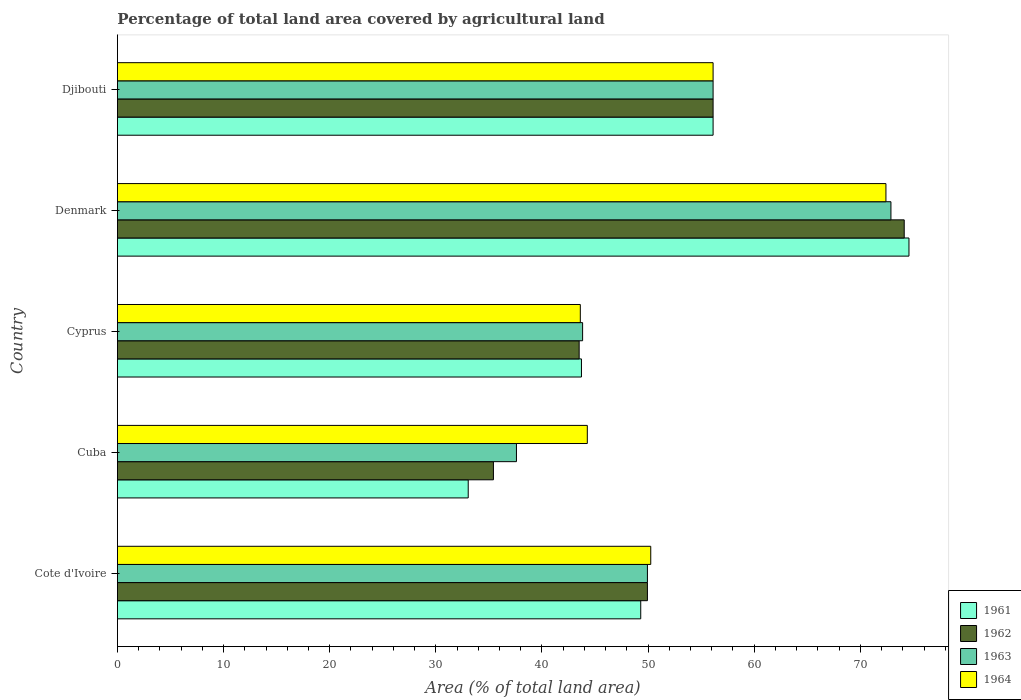How many different coloured bars are there?
Give a very brief answer. 4. What is the label of the 4th group of bars from the top?
Give a very brief answer. Cuba. What is the percentage of agricultural land in 1961 in Djibouti?
Provide a short and direct response. 56.13. Across all countries, what is the maximum percentage of agricultural land in 1964?
Offer a very short reply. 72.41. Across all countries, what is the minimum percentage of agricultural land in 1961?
Provide a short and direct response. 33.05. In which country was the percentage of agricultural land in 1962 maximum?
Provide a short and direct response. Denmark. In which country was the percentage of agricultural land in 1961 minimum?
Ensure brevity in your answer.  Cuba. What is the total percentage of agricultural land in 1964 in the graph?
Provide a short and direct response. 266.68. What is the difference between the percentage of agricultural land in 1961 in Cote d'Ivoire and that in Cuba?
Give a very brief answer. 16.25. What is the difference between the percentage of agricultural land in 1963 in Denmark and the percentage of agricultural land in 1961 in Djibouti?
Your answer should be compact. 16.76. What is the average percentage of agricultural land in 1961 per country?
Make the answer very short. 51.36. What is the difference between the percentage of agricultural land in 1962 and percentage of agricultural land in 1963 in Denmark?
Make the answer very short. 1.25. In how many countries, is the percentage of agricultural land in 1961 greater than 32 %?
Give a very brief answer. 5. What is the ratio of the percentage of agricultural land in 1964 in Cote d'Ivoire to that in Cyprus?
Provide a succinct answer. 1.15. Is the difference between the percentage of agricultural land in 1962 in Cyprus and Djibouti greater than the difference between the percentage of agricultural land in 1963 in Cyprus and Djibouti?
Keep it short and to the point. No. What is the difference between the highest and the second highest percentage of agricultural land in 1964?
Provide a short and direct response. 16.28. What is the difference between the highest and the lowest percentage of agricultural land in 1962?
Your answer should be very brief. 38.7. Is the sum of the percentage of agricultural land in 1961 in Cuba and Denmark greater than the maximum percentage of agricultural land in 1964 across all countries?
Offer a terse response. Yes. What does the 2nd bar from the bottom in Denmark represents?
Your answer should be very brief. 1962. How many countries are there in the graph?
Your answer should be very brief. 5. What is the difference between two consecutive major ticks on the X-axis?
Keep it short and to the point. 10. Are the values on the major ticks of X-axis written in scientific E-notation?
Keep it short and to the point. No. Does the graph contain any zero values?
Your response must be concise. No. Where does the legend appear in the graph?
Provide a succinct answer. Bottom right. How many legend labels are there?
Ensure brevity in your answer.  4. How are the legend labels stacked?
Give a very brief answer. Vertical. What is the title of the graph?
Keep it short and to the point. Percentage of total land area covered by agricultural land. What is the label or title of the X-axis?
Make the answer very short. Area (% of total land area). What is the Area (% of total land area) of 1961 in Cote d'Ivoire?
Offer a terse response. 49.31. What is the Area (% of total land area) in 1962 in Cote d'Ivoire?
Ensure brevity in your answer.  49.94. What is the Area (% of total land area) of 1963 in Cote d'Ivoire?
Provide a short and direct response. 49.94. What is the Area (% of total land area) of 1964 in Cote d'Ivoire?
Keep it short and to the point. 50.25. What is the Area (% of total land area) of 1961 in Cuba?
Offer a very short reply. 33.05. What is the Area (% of total land area) in 1962 in Cuba?
Provide a short and direct response. 35.43. What is the Area (% of total land area) in 1963 in Cuba?
Ensure brevity in your answer.  37.6. What is the Area (% of total land area) in 1964 in Cuba?
Keep it short and to the point. 44.27. What is the Area (% of total land area) of 1961 in Cyprus?
Your answer should be very brief. 43.72. What is the Area (% of total land area) in 1962 in Cyprus?
Offer a very short reply. 43.51. What is the Area (% of total land area) of 1963 in Cyprus?
Your answer should be very brief. 43.83. What is the Area (% of total land area) in 1964 in Cyprus?
Your answer should be very brief. 43.61. What is the Area (% of total land area) of 1961 in Denmark?
Offer a very short reply. 74.58. What is the Area (% of total land area) in 1962 in Denmark?
Your response must be concise. 74.13. What is the Area (% of total land area) of 1963 in Denmark?
Keep it short and to the point. 72.88. What is the Area (% of total land area) in 1964 in Denmark?
Offer a terse response. 72.41. What is the Area (% of total land area) of 1961 in Djibouti?
Your response must be concise. 56.13. What is the Area (% of total land area) of 1962 in Djibouti?
Your response must be concise. 56.13. What is the Area (% of total land area) of 1963 in Djibouti?
Your answer should be compact. 56.13. What is the Area (% of total land area) in 1964 in Djibouti?
Keep it short and to the point. 56.13. Across all countries, what is the maximum Area (% of total land area) in 1961?
Your answer should be very brief. 74.58. Across all countries, what is the maximum Area (% of total land area) of 1962?
Offer a very short reply. 74.13. Across all countries, what is the maximum Area (% of total land area) of 1963?
Offer a terse response. 72.88. Across all countries, what is the maximum Area (% of total land area) in 1964?
Ensure brevity in your answer.  72.41. Across all countries, what is the minimum Area (% of total land area) in 1961?
Provide a short and direct response. 33.05. Across all countries, what is the minimum Area (% of total land area) of 1962?
Provide a short and direct response. 35.43. Across all countries, what is the minimum Area (% of total land area) of 1963?
Provide a short and direct response. 37.6. Across all countries, what is the minimum Area (% of total land area) in 1964?
Offer a very short reply. 43.61. What is the total Area (% of total land area) in 1961 in the graph?
Your answer should be very brief. 256.79. What is the total Area (% of total land area) of 1962 in the graph?
Your answer should be compact. 259.13. What is the total Area (% of total land area) of 1963 in the graph?
Your answer should be very brief. 260.37. What is the total Area (% of total land area) in 1964 in the graph?
Your answer should be compact. 266.68. What is the difference between the Area (% of total land area) in 1961 in Cote d'Ivoire and that in Cuba?
Your answer should be compact. 16.25. What is the difference between the Area (% of total land area) of 1962 in Cote d'Ivoire and that in Cuba?
Ensure brevity in your answer.  14.51. What is the difference between the Area (% of total land area) in 1963 in Cote d'Ivoire and that in Cuba?
Ensure brevity in your answer.  12.34. What is the difference between the Area (% of total land area) in 1964 in Cote d'Ivoire and that in Cuba?
Ensure brevity in your answer.  5.98. What is the difference between the Area (% of total land area) of 1961 in Cote d'Ivoire and that in Cyprus?
Offer a very short reply. 5.59. What is the difference between the Area (% of total land area) in 1962 in Cote d'Ivoire and that in Cyprus?
Your answer should be very brief. 6.43. What is the difference between the Area (% of total land area) in 1963 in Cote d'Ivoire and that in Cyprus?
Offer a terse response. 6.11. What is the difference between the Area (% of total land area) in 1964 in Cote d'Ivoire and that in Cyprus?
Offer a terse response. 6.64. What is the difference between the Area (% of total land area) in 1961 in Cote d'Ivoire and that in Denmark?
Provide a short and direct response. -25.27. What is the difference between the Area (% of total land area) in 1962 in Cote d'Ivoire and that in Denmark?
Keep it short and to the point. -24.2. What is the difference between the Area (% of total land area) in 1963 in Cote d'Ivoire and that in Denmark?
Give a very brief answer. -22.94. What is the difference between the Area (% of total land area) in 1964 in Cote d'Ivoire and that in Denmark?
Your answer should be very brief. -22.16. What is the difference between the Area (% of total land area) of 1961 in Cote d'Ivoire and that in Djibouti?
Your answer should be compact. -6.82. What is the difference between the Area (% of total land area) of 1962 in Cote d'Ivoire and that in Djibouti?
Ensure brevity in your answer.  -6.19. What is the difference between the Area (% of total land area) in 1963 in Cote d'Ivoire and that in Djibouti?
Provide a succinct answer. -6.19. What is the difference between the Area (% of total land area) in 1964 in Cote d'Ivoire and that in Djibouti?
Your answer should be compact. -5.87. What is the difference between the Area (% of total land area) in 1961 in Cuba and that in Cyprus?
Offer a terse response. -10.67. What is the difference between the Area (% of total land area) of 1962 in Cuba and that in Cyprus?
Provide a succinct answer. -8.08. What is the difference between the Area (% of total land area) of 1963 in Cuba and that in Cyprus?
Your response must be concise. -6.23. What is the difference between the Area (% of total land area) in 1964 in Cuba and that in Cyprus?
Give a very brief answer. 0.66. What is the difference between the Area (% of total land area) in 1961 in Cuba and that in Denmark?
Provide a short and direct response. -41.53. What is the difference between the Area (% of total land area) in 1962 in Cuba and that in Denmark?
Give a very brief answer. -38.7. What is the difference between the Area (% of total land area) of 1963 in Cuba and that in Denmark?
Provide a succinct answer. -35.28. What is the difference between the Area (% of total land area) in 1964 in Cuba and that in Denmark?
Give a very brief answer. -28.14. What is the difference between the Area (% of total land area) in 1961 in Cuba and that in Djibouti?
Ensure brevity in your answer.  -23.07. What is the difference between the Area (% of total land area) of 1962 in Cuba and that in Djibouti?
Offer a very short reply. -20.7. What is the difference between the Area (% of total land area) in 1963 in Cuba and that in Djibouti?
Your answer should be compact. -18.53. What is the difference between the Area (% of total land area) in 1964 in Cuba and that in Djibouti?
Your answer should be compact. -11.85. What is the difference between the Area (% of total land area) of 1961 in Cyprus and that in Denmark?
Provide a short and direct response. -30.86. What is the difference between the Area (% of total land area) in 1962 in Cyprus and that in Denmark?
Your answer should be compact. -30.63. What is the difference between the Area (% of total land area) in 1963 in Cyprus and that in Denmark?
Give a very brief answer. -29.05. What is the difference between the Area (% of total land area) in 1964 in Cyprus and that in Denmark?
Offer a terse response. -28.8. What is the difference between the Area (% of total land area) of 1961 in Cyprus and that in Djibouti?
Offer a very short reply. -12.4. What is the difference between the Area (% of total land area) of 1962 in Cyprus and that in Djibouti?
Make the answer very short. -12.62. What is the difference between the Area (% of total land area) of 1963 in Cyprus and that in Djibouti?
Ensure brevity in your answer.  -12.29. What is the difference between the Area (% of total land area) in 1964 in Cyprus and that in Djibouti?
Keep it short and to the point. -12.51. What is the difference between the Area (% of total land area) in 1961 in Denmark and that in Djibouti?
Keep it short and to the point. 18.46. What is the difference between the Area (% of total land area) in 1962 in Denmark and that in Djibouti?
Your answer should be very brief. 18.01. What is the difference between the Area (% of total land area) in 1963 in Denmark and that in Djibouti?
Give a very brief answer. 16.76. What is the difference between the Area (% of total land area) of 1964 in Denmark and that in Djibouti?
Make the answer very short. 16.28. What is the difference between the Area (% of total land area) in 1961 in Cote d'Ivoire and the Area (% of total land area) in 1962 in Cuba?
Give a very brief answer. 13.88. What is the difference between the Area (% of total land area) in 1961 in Cote d'Ivoire and the Area (% of total land area) in 1963 in Cuba?
Provide a succinct answer. 11.71. What is the difference between the Area (% of total land area) of 1961 in Cote d'Ivoire and the Area (% of total land area) of 1964 in Cuba?
Your answer should be very brief. 5.03. What is the difference between the Area (% of total land area) of 1962 in Cote d'Ivoire and the Area (% of total land area) of 1963 in Cuba?
Offer a very short reply. 12.34. What is the difference between the Area (% of total land area) in 1962 in Cote d'Ivoire and the Area (% of total land area) in 1964 in Cuba?
Ensure brevity in your answer.  5.66. What is the difference between the Area (% of total land area) in 1963 in Cote d'Ivoire and the Area (% of total land area) in 1964 in Cuba?
Provide a short and direct response. 5.66. What is the difference between the Area (% of total land area) in 1961 in Cote d'Ivoire and the Area (% of total land area) in 1962 in Cyprus?
Your answer should be compact. 5.8. What is the difference between the Area (% of total land area) of 1961 in Cote d'Ivoire and the Area (% of total land area) of 1963 in Cyprus?
Offer a very short reply. 5.48. What is the difference between the Area (% of total land area) of 1961 in Cote d'Ivoire and the Area (% of total land area) of 1964 in Cyprus?
Give a very brief answer. 5.69. What is the difference between the Area (% of total land area) of 1962 in Cote d'Ivoire and the Area (% of total land area) of 1963 in Cyprus?
Provide a short and direct response. 6.11. What is the difference between the Area (% of total land area) of 1962 in Cote d'Ivoire and the Area (% of total land area) of 1964 in Cyprus?
Provide a succinct answer. 6.32. What is the difference between the Area (% of total land area) of 1963 in Cote d'Ivoire and the Area (% of total land area) of 1964 in Cyprus?
Make the answer very short. 6.32. What is the difference between the Area (% of total land area) in 1961 in Cote d'Ivoire and the Area (% of total land area) in 1962 in Denmark?
Your answer should be very brief. -24.82. What is the difference between the Area (% of total land area) of 1961 in Cote d'Ivoire and the Area (% of total land area) of 1963 in Denmark?
Make the answer very short. -23.57. What is the difference between the Area (% of total land area) of 1961 in Cote d'Ivoire and the Area (% of total land area) of 1964 in Denmark?
Keep it short and to the point. -23.1. What is the difference between the Area (% of total land area) of 1962 in Cote d'Ivoire and the Area (% of total land area) of 1963 in Denmark?
Offer a very short reply. -22.94. What is the difference between the Area (% of total land area) of 1962 in Cote d'Ivoire and the Area (% of total land area) of 1964 in Denmark?
Your answer should be very brief. -22.47. What is the difference between the Area (% of total land area) in 1963 in Cote d'Ivoire and the Area (% of total land area) in 1964 in Denmark?
Provide a short and direct response. -22.47. What is the difference between the Area (% of total land area) in 1961 in Cote d'Ivoire and the Area (% of total land area) in 1962 in Djibouti?
Keep it short and to the point. -6.82. What is the difference between the Area (% of total land area) in 1961 in Cote d'Ivoire and the Area (% of total land area) in 1963 in Djibouti?
Keep it short and to the point. -6.82. What is the difference between the Area (% of total land area) of 1961 in Cote d'Ivoire and the Area (% of total land area) of 1964 in Djibouti?
Your answer should be very brief. -6.82. What is the difference between the Area (% of total land area) of 1962 in Cote d'Ivoire and the Area (% of total land area) of 1963 in Djibouti?
Offer a very short reply. -6.19. What is the difference between the Area (% of total land area) in 1962 in Cote d'Ivoire and the Area (% of total land area) in 1964 in Djibouti?
Give a very brief answer. -6.19. What is the difference between the Area (% of total land area) of 1963 in Cote d'Ivoire and the Area (% of total land area) of 1964 in Djibouti?
Provide a succinct answer. -6.19. What is the difference between the Area (% of total land area) of 1961 in Cuba and the Area (% of total land area) of 1962 in Cyprus?
Offer a terse response. -10.45. What is the difference between the Area (% of total land area) of 1961 in Cuba and the Area (% of total land area) of 1963 in Cyprus?
Offer a terse response. -10.78. What is the difference between the Area (% of total land area) of 1961 in Cuba and the Area (% of total land area) of 1964 in Cyprus?
Your answer should be very brief. -10.56. What is the difference between the Area (% of total land area) in 1962 in Cuba and the Area (% of total land area) in 1963 in Cyprus?
Ensure brevity in your answer.  -8.4. What is the difference between the Area (% of total land area) in 1962 in Cuba and the Area (% of total land area) in 1964 in Cyprus?
Your answer should be very brief. -8.19. What is the difference between the Area (% of total land area) in 1963 in Cuba and the Area (% of total land area) in 1964 in Cyprus?
Keep it short and to the point. -6.02. What is the difference between the Area (% of total land area) in 1961 in Cuba and the Area (% of total land area) in 1962 in Denmark?
Offer a terse response. -41.08. What is the difference between the Area (% of total land area) of 1961 in Cuba and the Area (% of total land area) of 1963 in Denmark?
Ensure brevity in your answer.  -39.83. What is the difference between the Area (% of total land area) of 1961 in Cuba and the Area (% of total land area) of 1964 in Denmark?
Provide a short and direct response. -39.36. What is the difference between the Area (% of total land area) in 1962 in Cuba and the Area (% of total land area) in 1963 in Denmark?
Provide a succinct answer. -37.45. What is the difference between the Area (% of total land area) in 1962 in Cuba and the Area (% of total land area) in 1964 in Denmark?
Offer a terse response. -36.98. What is the difference between the Area (% of total land area) in 1963 in Cuba and the Area (% of total land area) in 1964 in Denmark?
Ensure brevity in your answer.  -34.81. What is the difference between the Area (% of total land area) of 1961 in Cuba and the Area (% of total land area) of 1962 in Djibouti?
Provide a short and direct response. -23.07. What is the difference between the Area (% of total land area) in 1961 in Cuba and the Area (% of total land area) in 1963 in Djibouti?
Your response must be concise. -23.07. What is the difference between the Area (% of total land area) in 1961 in Cuba and the Area (% of total land area) in 1964 in Djibouti?
Make the answer very short. -23.07. What is the difference between the Area (% of total land area) in 1962 in Cuba and the Area (% of total land area) in 1963 in Djibouti?
Make the answer very short. -20.7. What is the difference between the Area (% of total land area) in 1962 in Cuba and the Area (% of total land area) in 1964 in Djibouti?
Make the answer very short. -20.7. What is the difference between the Area (% of total land area) in 1963 in Cuba and the Area (% of total land area) in 1964 in Djibouti?
Make the answer very short. -18.53. What is the difference between the Area (% of total land area) of 1961 in Cyprus and the Area (% of total land area) of 1962 in Denmark?
Give a very brief answer. -30.41. What is the difference between the Area (% of total land area) of 1961 in Cyprus and the Area (% of total land area) of 1963 in Denmark?
Your answer should be compact. -29.16. What is the difference between the Area (% of total land area) of 1961 in Cyprus and the Area (% of total land area) of 1964 in Denmark?
Offer a very short reply. -28.69. What is the difference between the Area (% of total land area) in 1962 in Cyprus and the Area (% of total land area) in 1963 in Denmark?
Your answer should be compact. -29.38. What is the difference between the Area (% of total land area) of 1962 in Cyprus and the Area (% of total land area) of 1964 in Denmark?
Provide a succinct answer. -28.9. What is the difference between the Area (% of total land area) of 1963 in Cyprus and the Area (% of total land area) of 1964 in Denmark?
Ensure brevity in your answer.  -28.58. What is the difference between the Area (% of total land area) in 1961 in Cyprus and the Area (% of total land area) in 1962 in Djibouti?
Your response must be concise. -12.4. What is the difference between the Area (% of total land area) of 1961 in Cyprus and the Area (% of total land area) of 1963 in Djibouti?
Offer a terse response. -12.4. What is the difference between the Area (% of total land area) of 1961 in Cyprus and the Area (% of total land area) of 1964 in Djibouti?
Provide a short and direct response. -12.4. What is the difference between the Area (% of total land area) of 1962 in Cyprus and the Area (% of total land area) of 1963 in Djibouti?
Your answer should be very brief. -12.62. What is the difference between the Area (% of total land area) of 1962 in Cyprus and the Area (% of total land area) of 1964 in Djibouti?
Ensure brevity in your answer.  -12.62. What is the difference between the Area (% of total land area) of 1963 in Cyprus and the Area (% of total land area) of 1964 in Djibouti?
Make the answer very short. -12.29. What is the difference between the Area (% of total land area) of 1961 in Denmark and the Area (% of total land area) of 1962 in Djibouti?
Provide a succinct answer. 18.46. What is the difference between the Area (% of total land area) of 1961 in Denmark and the Area (% of total land area) of 1963 in Djibouti?
Ensure brevity in your answer.  18.46. What is the difference between the Area (% of total land area) in 1961 in Denmark and the Area (% of total land area) in 1964 in Djibouti?
Give a very brief answer. 18.46. What is the difference between the Area (% of total land area) of 1962 in Denmark and the Area (% of total land area) of 1963 in Djibouti?
Ensure brevity in your answer.  18.01. What is the difference between the Area (% of total land area) in 1962 in Denmark and the Area (% of total land area) in 1964 in Djibouti?
Keep it short and to the point. 18.01. What is the difference between the Area (% of total land area) of 1963 in Denmark and the Area (% of total land area) of 1964 in Djibouti?
Your response must be concise. 16.76. What is the average Area (% of total land area) of 1961 per country?
Ensure brevity in your answer.  51.36. What is the average Area (% of total land area) in 1962 per country?
Give a very brief answer. 51.83. What is the average Area (% of total land area) of 1963 per country?
Ensure brevity in your answer.  52.07. What is the average Area (% of total land area) of 1964 per country?
Offer a very short reply. 53.34. What is the difference between the Area (% of total land area) of 1961 and Area (% of total land area) of 1962 in Cote d'Ivoire?
Provide a short and direct response. -0.63. What is the difference between the Area (% of total land area) of 1961 and Area (% of total land area) of 1963 in Cote d'Ivoire?
Provide a succinct answer. -0.63. What is the difference between the Area (% of total land area) in 1961 and Area (% of total land area) in 1964 in Cote d'Ivoire?
Your answer should be very brief. -0.94. What is the difference between the Area (% of total land area) in 1962 and Area (% of total land area) in 1963 in Cote d'Ivoire?
Your answer should be very brief. 0. What is the difference between the Area (% of total land area) in 1962 and Area (% of total land area) in 1964 in Cote d'Ivoire?
Keep it short and to the point. -0.31. What is the difference between the Area (% of total land area) of 1963 and Area (% of total land area) of 1964 in Cote d'Ivoire?
Keep it short and to the point. -0.31. What is the difference between the Area (% of total land area) of 1961 and Area (% of total land area) of 1962 in Cuba?
Offer a very short reply. -2.37. What is the difference between the Area (% of total land area) of 1961 and Area (% of total land area) of 1963 in Cuba?
Give a very brief answer. -4.54. What is the difference between the Area (% of total land area) in 1961 and Area (% of total land area) in 1964 in Cuba?
Your response must be concise. -11.22. What is the difference between the Area (% of total land area) of 1962 and Area (% of total land area) of 1963 in Cuba?
Offer a terse response. -2.17. What is the difference between the Area (% of total land area) in 1962 and Area (% of total land area) in 1964 in Cuba?
Give a very brief answer. -8.85. What is the difference between the Area (% of total land area) of 1963 and Area (% of total land area) of 1964 in Cuba?
Your answer should be very brief. -6.68. What is the difference between the Area (% of total land area) in 1961 and Area (% of total land area) in 1962 in Cyprus?
Offer a very short reply. 0.22. What is the difference between the Area (% of total land area) of 1961 and Area (% of total land area) of 1963 in Cyprus?
Keep it short and to the point. -0.11. What is the difference between the Area (% of total land area) of 1961 and Area (% of total land area) of 1964 in Cyprus?
Your answer should be very brief. 0.11. What is the difference between the Area (% of total land area) of 1962 and Area (% of total land area) of 1963 in Cyprus?
Your answer should be compact. -0.32. What is the difference between the Area (% of total land area) in 1962 and Area (% of total land area) in 1964 in Cyprus?
Ensure brevity in your answer.  -0.11. What is the difference between the Area (% of total land area) in 1963 and Area (% of total land area) in 1964 in Cyprus?
Ensure brevity in your answer.  0.22. What is the difference between the Area (% of total land area) of 1961 and Area (% of total land area) of 1962 in Denmark?
Make the answer very short. 0.45. What is the difference between the Area (% of total land area) in 1961 and Area (% of total land area) in 1963 in Denmark?
Provide a short and direct response. 1.7. What is the difference between the Area (% of total land area) of 1961 and Area (% of total land area) of 1964 in Denmark?
Make the answer very short. 2.17. What is the difference between the Area (% of total land area) of 1962 and Area (% of total land area) of 1963 in Denmark?
Ensure brevity in your answer.  1.25. What is the difference between the Area (% of total land area) of 1962 and Area (% of total land area) of 1964 in Denmark?
Keep it short and to the point. 1.72. What is the difference between the Area (% of total land area) of 1963 and Area (% of total land area) of 1964 in Denmark?
Your answer should be compact. 0.47. What is the difference between the Area (% of total land area) of 1961 and Area (% of total land area) of 1964 in Djibouti?
Your response must be concise. 0. What is the difference between the Area (% of total land area) in 1962 and Area (% of total land area) in 1963 in Djibouti?
Your answer should be very brief. 0. What is the difference between the Area (% of total land area) of 1962 and Area (% of total land area) of 1964 in Djibouti?
Keep it short and to the point. 0. What is the ratio of the Area (% of total land area) in 1961 in Cote d'Ivoire to that in Cuba?
Keep it short and to the point. 1.49. What is the ratio of the Area (% of total land area) in 1962 in Cote d'Ivoire to that in Cuba?
Offer a very short reply. 1.41. What is the ratio of the Area (% of total land area) of 1963 in Cote d'Ivoire to that in Cuba?
Your answer should be very brief. 1.33. What is the ratio of the Area (% of total land area) of 1964 in Cote d'Ivoire to that in Cuba?
Your response must be concise. 1.14. What is the ratio of the Area (% of total land area) in 1961 in Cote d'Ivoire to that in Cyprus?
Offer a terse response. 1.13. What is the ratio of the Area (% of total land area) in 1962 in Cote d'Ivoire to that in Cyprus?
Offer a very short reply. 1.15. What is the ratio of the Area (% of total land area) in 1963 in Cote d'Ivoire to that in Cyprus?
Your response must be concise. 1.14. What is the ratio of the Area (% of total land area) of 1964 in Cote d'Ivoire to that in Cyprus?
Keep it short and to the point. 1.15. What is the ratio of the Area (% of total land area) of 1961 in Cote d'Ivoire to that in Denmark?
Offer a terse response. 0.66. What is the ratio of the Area (% of total land area) in 1962 in Cote d'Ivoire to that in Denmark?
Provide a succinct answer. 0.67. What is the ratio of the Area (% of total land area) of 1963 in Cote d'Ivoire to that in Denmark?
Give a very brief answer. 0.69. What is the ratio of the Area (% of total land area) of 1964 in Cote d'Ivoire to that in Denmark?
Offer a terse response. 0.69. What is the ratio of the Area (% of total land area) in 1961 in Cote d'Ivoire to that in Djibouti?
Give a very brief answer. 0.88. What is the ratio of the Area (% of total land area) in 1962 in Cote d'Ivoire to that in Djibouti?
Offer a terse response. 0.89. What is the ratio of the Area (% of total land area) of 1963 in Cote d'Ivoire to that in Djibouti?
Give a very brief answer. 0.89. What is the ratio of the Area (% of total land area) of 1964 in Cote d'Ivoire to that in Djibouti?
Ensure brevity in your answer.  0.9. What is the ratio of the Area (% of total land area) of 1961 in Cuba to that in Cyprus?
Give a very brief answer. 0.76. What is the ratio of the Area (% of total land area) in 1962 in Cuba to that in Cyprus?
Your answer should be compact. 0.81. What is the ratio of the Area (% of total land area) in 1963 in Cuba to that in Cyprus?
Offer a very short reply. 0.86. What is the ratio of the Area (% of total land area) of 1964 in Cuba to that in Cyprus?
Provide a short and direct response. 1.02. What is the ratio of the Area (% of total land area) in 1961 in Cuba to that in Denmark?
Provide a succinct answer. 0.44. What is the ratio of the Area (% of total land area) in 1962 in Cuba to that in Denmark?
Ensure brevity in your answer.  0.48. What is the ratio of the Area (% of total land area) in 1963 in Cuba to that in Denmark?
Make the answer very short. 0.52. What is the ratio of the Area (% of total land area) of 1964 in Cuba to that in Denmark?
Your answer should be very brief. 0.61. What is the ratio of the Area (% of total land area) in 1961 in Cuba to that in Djibouti?
Offer a terse response. 0.59. What is the ratio of the Area (% of total land area) of 1962 in Cuba to that in Djibouti?
Your response must be concise. 0.63. What is the ratio of the Area (% of total land area) of 1963 in Cuba to that in Djibouti?
Offer a terse response. 0.67. What is the ratio of the Area (% of total land area) in 1964 in Cuba to that in Djibouti?
Your answer should be compact. 0.79. What is the ratio of the Area (% of total land area) of 1961 in Cyprus to that in Denmark?
Offer a very short reply. 0.59. What is the ratio of the Area (% of total land area) in 1962 in Cyprus to that in Denmark?
Ensure brevity in your answer.  0.59. What is the ratio of the Area (% of total land area) in 1963 in Cyprus to that in Denmark?
Keep it short and to the point. 0.6. What is the ratio of the Area (% of total land area) of 1964 in Cyprus to that in Denmark?
Give a very brief answer. 0.6. What is the ratio of the Area (% of total land area) of 1961 in Cyprus to that in Djibouti?
Your answer should be compact. 0.78. What is the ratio of the Area (% of total land area) of 1962 in Cyprus to that in Djibouti?
Ensure brevity in your answer.  0.78. What is the ratio of the Area (% of total land area) in 1963 in Cyprus to that in Djibouti?
Your answer should be very brief. 0.78. What is the ratio of the Area (% of total land area) of 1964 in Cyprus to that in Djibouti?
Ensure brevity in your answer.  0.78. What is the ratio of the Area (% of total land area) of 1961 in Denmark to that in Djibouti?
Your answer should be very brief. 1.33. What is the ratio of the Area (% of total land area) of 1962 in Denmark to that in Djibouti?
Make the answer very short. 1.32. What is the ratio of the Area (% of total land area) in 1963 in Denmark to that in Djibouti?
Offer a very short reply. 1.3. What is the ratio of the Area (% of total land area) of 1964 in Denmark to that in Djibouti?
Give a very brief answer. 1.29. What is the difference between the highest and the second highest Area (% of total land area) in 1961?
Offer a terse response. 18.46. What is the difference between the highest and the second highest Area (% of total land area) of 1962?
Keep it short and to the point. 18.01. What is the difference between the highest and the second highest Area (% of total land area) in 1963?
Provide a short and direct response. 16.76. What is the difference between the highest and the second highest Area (% of total land area) of 1964?
Your answer should be compact. 16.28. What is the difference between the highest and the lowest Area (% of total land area) in 1961?
Offer a very short reply. 41.53. What is the difference between the highest and the lowest Area (% of total land area) of 1962?
Offer a terse response. 38.7. What is the difference between the highest and the lowest Area (% of total land area) in 1963?
Give a very brief answer. 35.28. What is the difference between the highest and the lowest Area (% of total land area) in 1964?
Your answer should be very brief. 28.8. 